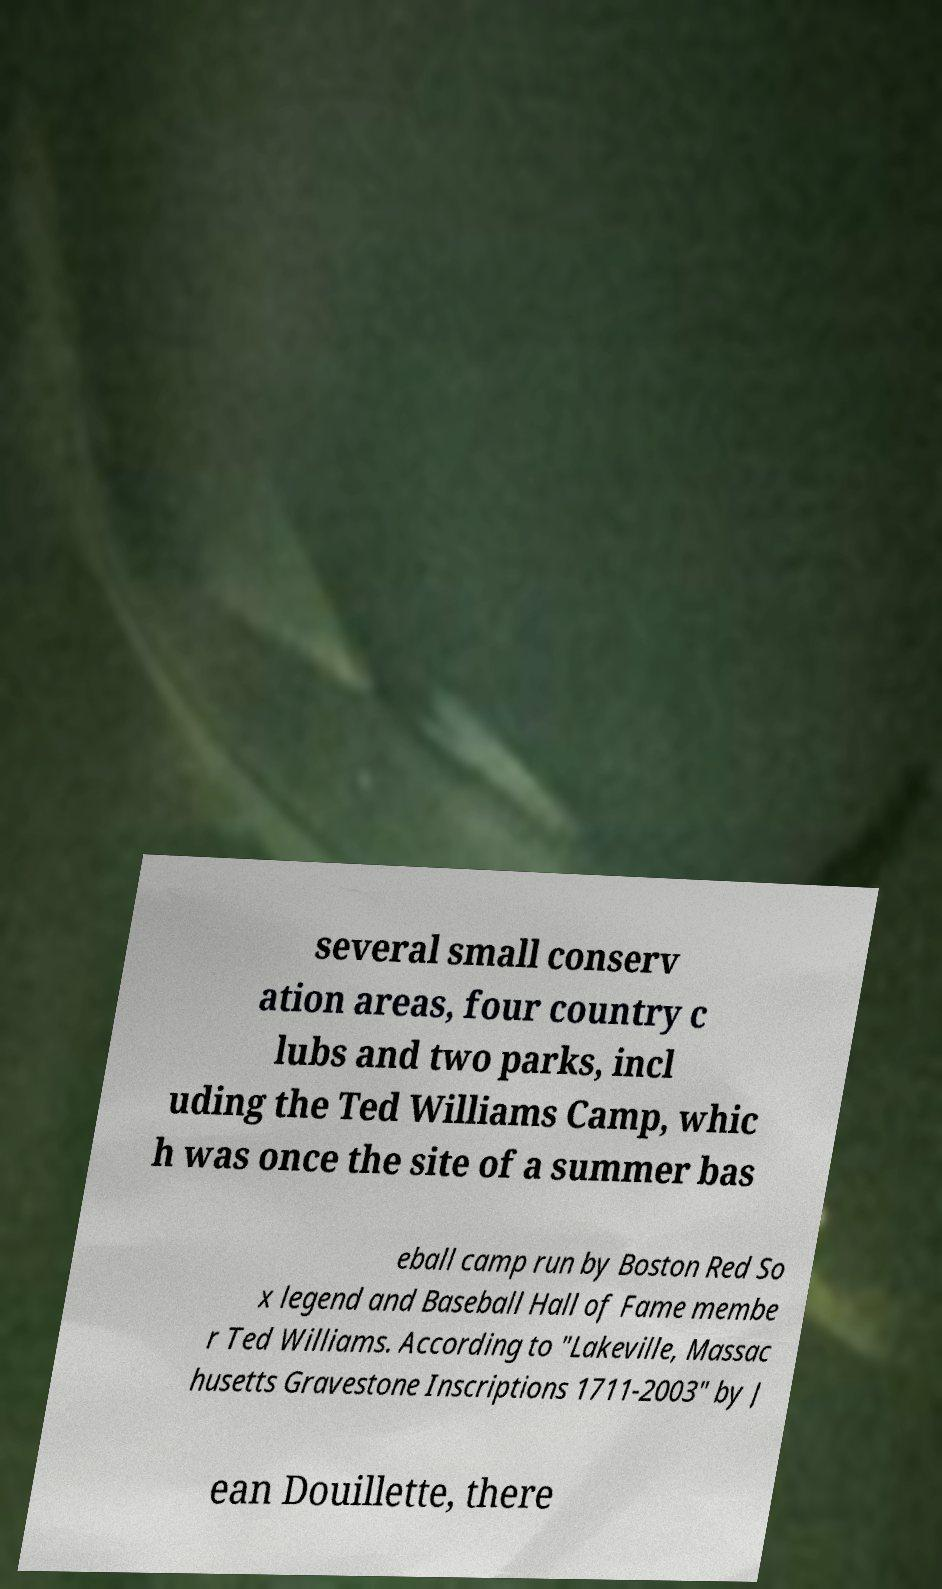Could you assist in decoding the text presented in this image and type it out clearly? several small conserv ation areas, four country c lubs and two parks, incl uding the Ted Williams Camp, whic h was once the site of a summer bas eball camp run by Boston Red So x legend and Baseball Hall of Fame membe r Ted Williams. According to "Lakeville, Massac husetts Gravestone Inscriptions 1711-2003" by J ean Douillette, there 